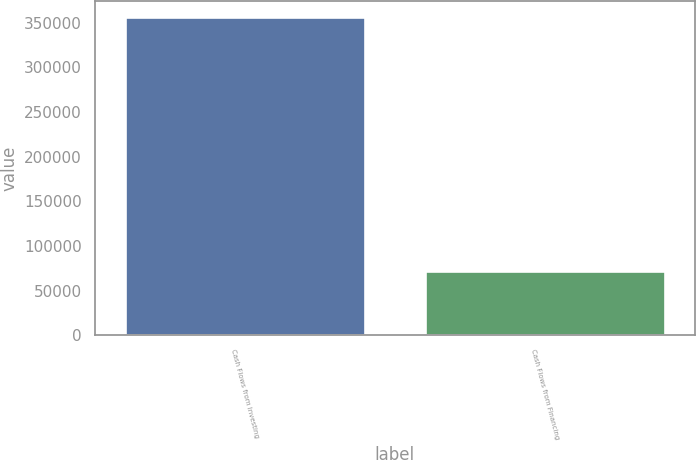Convert chart to OTSL. <chart><loc_0><loc_0><loc_500><loc_500><bar_chart><fcel>Cash Flows from Investing<fcel>Cash Flows from Financing<nl><fcel>356012<fcel>72313<nl></chart> 